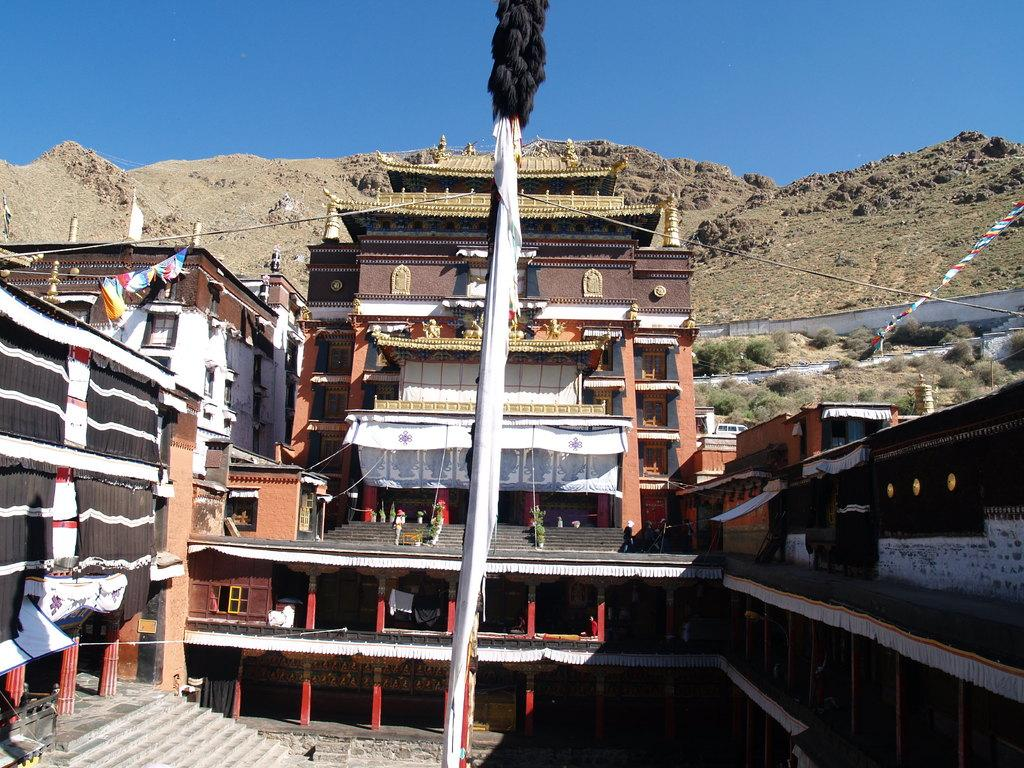What is located in the foreground of the image? There is a curtain in the foreground of the image. What type of structures can be seen in the image? There are house structures in the image. Are there any other curtains visible besides the one in the foreground? Yes, there are curtains visible in the image. What architectural feature is present in the image? There are stairs in the image. What type of natural environment is present in the image? Greenery is present in the image. What can be seen in the background of the image? There are mountains and the sky visible in the background of the image. What type of quiver is hanging on the side of the house in the image? There is no quiver present in the image; it features a curtain, house structures, curtains, stairs, greenery, mountains, and the sky. 